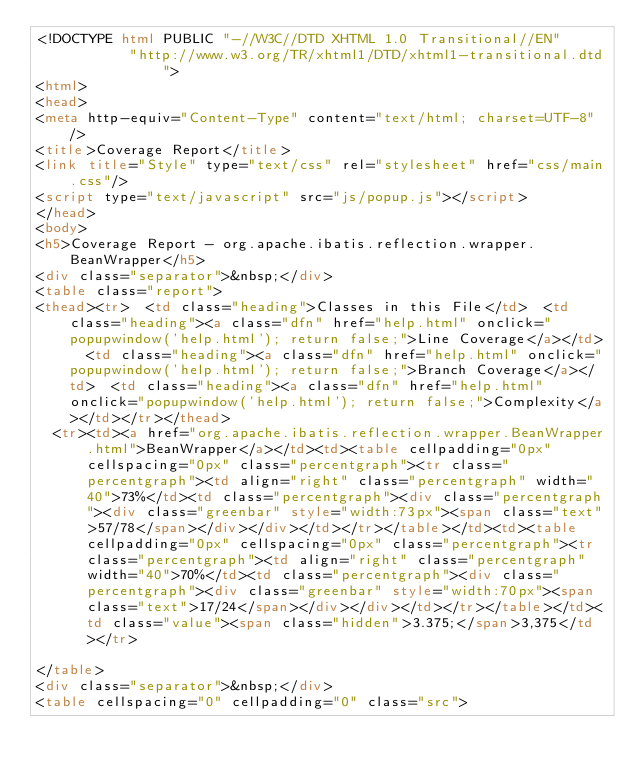Convert code to text. <code><loc_0><loc_0><loc_500><loc_500><_HTML_><!DOCTYPE html PUBLIC "-//W3C//DTD XHTML 1.0 Transitional//EN"
           "http://www.w3.org/TR/xhtml1/DTD/xhtml1-transitional.dtd">
<html>
<head>
<meta http-equiv="Content-Type" content="text/html; charset=UTF-8"/>
<title>Coverage Report</title>
<link title="Style" type="text/css" rel="stylesheet" href="css/main.css"/>
<script type="text/javascript" src="js/popup.js"></script>
</head>
<body>
<h5>Coverage Report - org.apache.ibatis.reflection.wrapper.BeanWrapper</h5>
<div class="separator">&nbsp;</div>
<table class="report">
<thead><tr>  <td class="heading">Classes in this File</td>  <td class="heading"><a class="dfn" href="help.html" onclick="popupwindow('help.html'); return false;">Line Coverage</a></td>  <td class="heading"><a class="dfn" href="help.html" onclick="popupwindow('help.html'); return false;">Branch Coverage</a></td>  <td class="heading"><a class="dfn" href="help.html" onclick="popupwindow('help.html'); return false;">Complexity</a></td></tr></thead>
  <tr><td><a href="org.apache.ibatis.reflection.wrapper.BeanWrapper.html">BeanWrapper</a></td><td><table cellpadding="0px" cellspacing="0px" class="percentgraph"><tr class="percentgraph"><td align="right" class="percentgraph" width="40">73%</td><td class="percentgraph"><div class="percentgraph"><div class="greenbar" style="width:73px"><span class="text">57/78</span></div></div></td></tr></table></td><td><table cellpadding="0px" cellspacing="0px" class="percentgraph"><tr class="percentgraph"><td align="right" class="percentgraph" width="40">70%</td><td class="percentgraph"><div class="percentgraph"><div class="greenbar" style="width:70px"><span class="text">17/24</span></div></div></td></tr></table></td><td class="value"><span class="hidden">3.375;</span>3,375</td></tr>

</table>
<div class="separator">&nbsp;</div>
<table cellspacing="0" cellpadding="0" class="src"></code> 